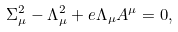Convert formula to latex. <formula><loc_0><loc_0><loc_500><loc_500>\Sigma _ { \mu } ^ { 2 } - \Lambda _ { \mu } ^ { 2 } + e \Lambda _ { \mu } A ^ { \mu } = 0 ,</formula> 